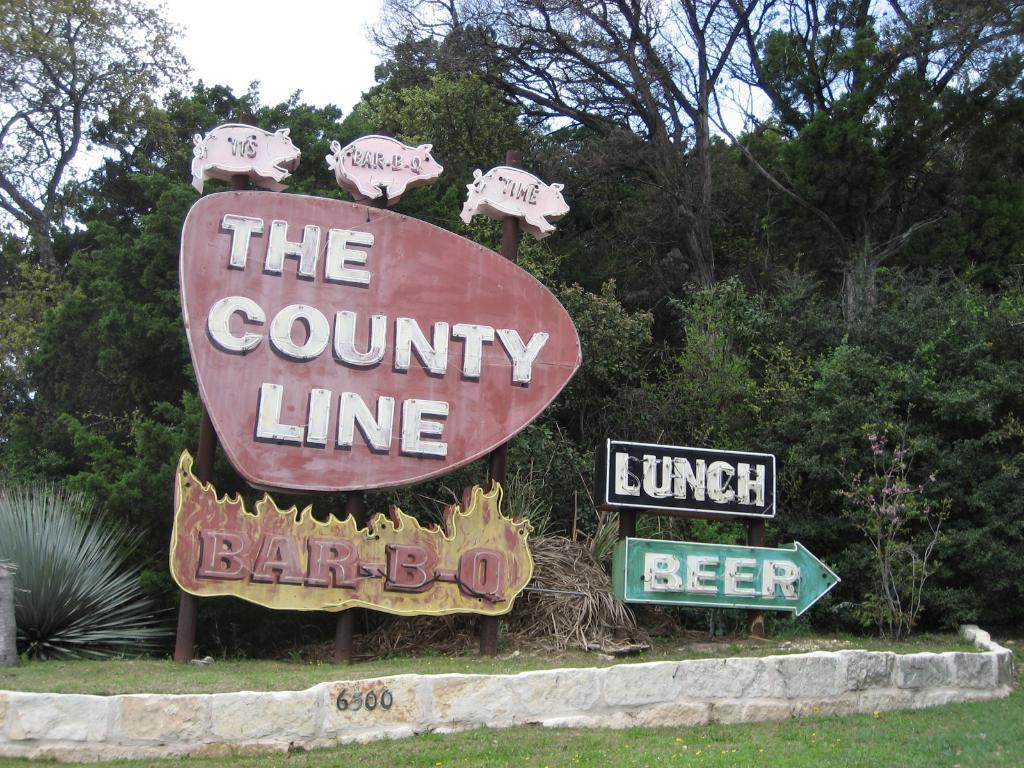What structures are present on poles in the image? There are boards on poles in the image. What type of barrier can be seen in the image? There is a wall in the image. What type of vegetation is present in the image? There is grass, plants, and trees in the image. What part of the natural environment is visible in the image? The sky is visible in the background of the image. How does the distribution of water occur in the image? There is no reference to water or distribution in the image, so it is not possible to answer that question. 